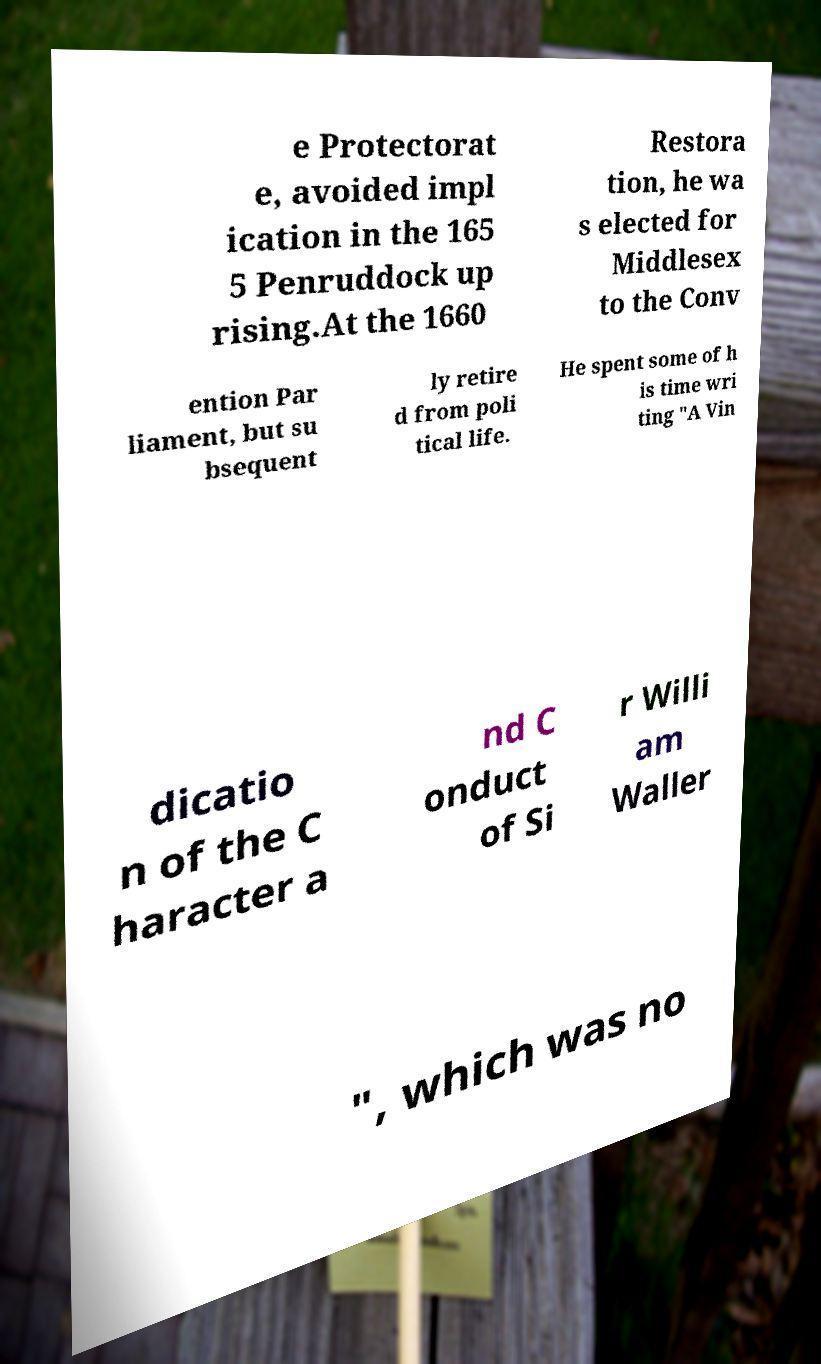Please read and relay the text visible in this image. What does it say? e Protectorat e, avoided impl ication in the 165 5 Penruddock up rising.At the 1660 Restora tion, he wa s elected for Middlesex to the Conv ention Par liament, but su bsequent ly retire d from poli tical life. He spent some of h is time wri ting "A Vin dicatio n of the C haracter a nd C onduct of Si r Willi am Waller ", which was no 